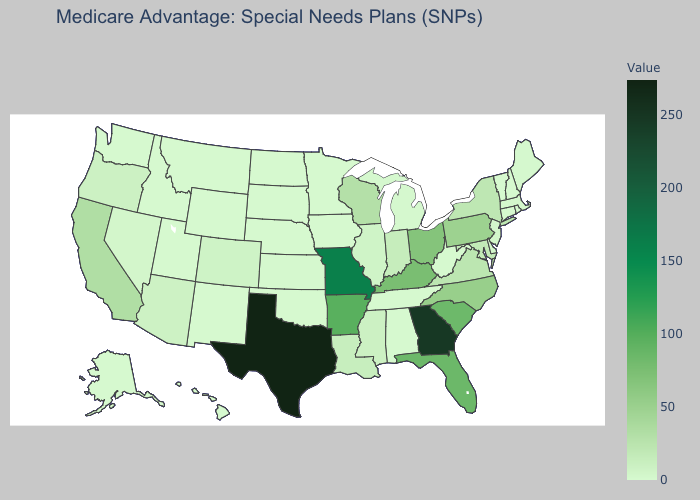Does Utah have the highest value in the West?
Quick response, please. No. Does Texas have the highest value in the USA?
Write a very short answer. Yes. Does North Dakota have the lowest value in the MidWest?
Keep it brief. Yes. Among the states that border Oregon , which have the lowest value?
Quick response, please. Idaho, Washington. Which states have the highest value in the USA?
Short answer required. Texas. Which states have the lowest value in the USA?
Concise answer only. Alaska, Alabama, Connecticut, Hawaii, Iowa, Idaho, Minnesota, Montana, North Dakota, Nebraska, New Hampshire, New Mexico, Oklahoma, Rhode Island, South Dakota, Tennessee, Utah, Vermont, Washington, West Virginia, Wyoming. Does Maine have the lowest value in the Northeast?
Answer briefly. No. Which states hav the highest value in the Northeast?
Keep it brief. Pennsylvania. 